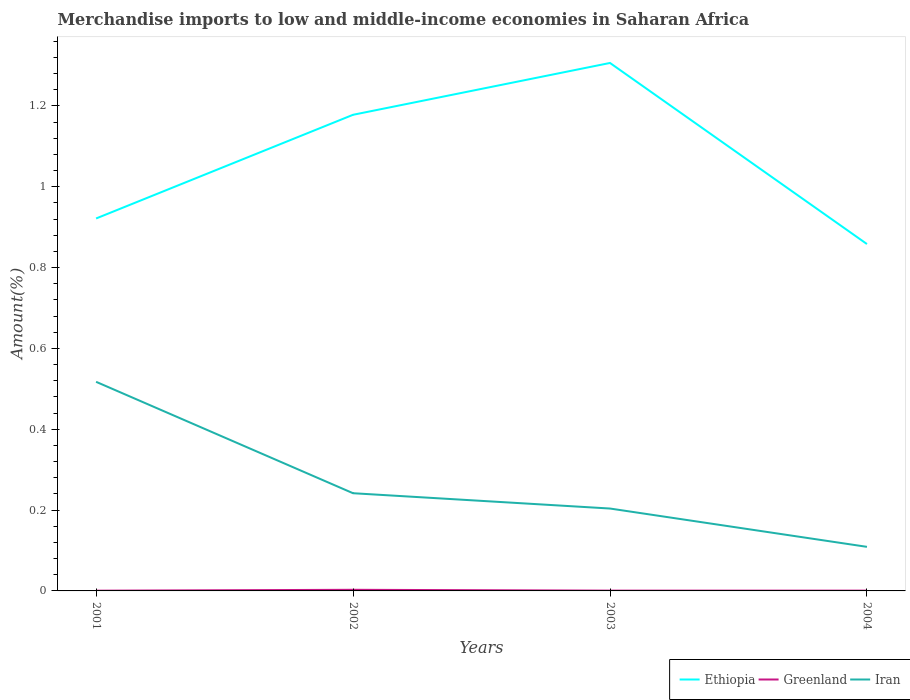Does the line corresponding to Ethiopia intersect with the line corresponding to Greenland?
Your answer should be compact. No. Across all years, what is the maximum percentage of amount earned from merchandise imports in Iran?
Your answer should be very brief. 0.11. What is the total percentage of amount earned from merchandise imports in Ethiopia in the graph?
Your answer should be compact. -0.26. What is the difference between the highest and the second highest percentage of amount earned from merchandise imports in Ethiopia?
Your answer should be very brief. 0.45. What is the difference between the highest and the lowest percentage of amount earned from merchandise imports in Ethiopia?
Provide a short and direct response. 2. How many lines are there?
Make the answer very short. 3. How many years are there in the graph?
Your answer should be very brief. 4. What is the difference between two consecutive major ticks on the Y-axis?
Your answer should be compact. 0.2. Are the values on the major ticks of Y-axis written in scientific E-notation?
Your answer should be compact. No. Does the graph contain grids?
Your answer should be very brief. No. What is the title of the graph?
Ensure brevity in your answer.  Merchandise imports to low and middle-income economies in Saharan Africa. What is the label or title of the X-axis?
Your response must be concise. Years. What is the label or title of the Y-axis?
Provide a short and direct response. Amount(%). What is the Amount(%) in Ethiopia in 2001?
Provide a succinct answer. 0.92. What is the Amount(%) of Greenland in 2001?
Offer a very short reply. 0. What is the Amount(%) in Iran in 2001?
Keep it short and to the point. 0.52. What is the Amount(%) in Ethiopia in 2002?
Provide a succinct answer. 1.18. What is the Amount(%) in Greenland in 2002?
Your response must be concise. 0. What is the Amount(%) of Iran in 2002?
Your answer should be compact. 0.24. What is the Amount(%) in Ethiopia in 2003?
Ensure brevity in your answer.  1.31. What is the Amount(%) in Greenland in 2003?
Offer a terse response. 0. What is the Amount(%) of Iran in 2003?
Keep it short and to the point. 0.2. What is the Amount(%) in Ethiopia in 2004?
Make the answer very short. 0.86. What is the Amount(%) in Greenland in 2004?
Your response must be concise. 0. What is the Amount(%) in Iran in 2004?
Offer a terse response. 0.11. Across all years, what is the maximum Amount(%) of Ethiopia?
Ensure brevity in your answer.  1.31. Across all years, what is the maximum Amount(%) in Greenland?
Give a very brief answer. 0. Across all years, what is the maximum Amount(%) of Iran?
Make the answer very short. 0.52. Across all years, what is the minimum Amount(%) of Ethiopia?
Your answer should be very brief. 0.86. Across all years, what is the minimum Amount(%) of Greenland?
Offer a terse response. 0. Across all years, what is the minimum Amount(%) of Iran?
Give a very brief answer. 0.11. What is the total Amount(%) in Ethiopia in the graph?
Make the answer very short. 4.26. What is the total Amount(%) of Greenland in the graph?
Provide a succinct answer. 0. What is the total Amount(%) of Iran in the graph?
Make the answer very short. 1.07. What is the difference between the Amount(%) in Ethiopia in 2001 and that in 2002?
Your response must be concise. -0.26. What is the difference between the Amount(%) of Greenland in 2001 and that in 2002?
Your response must be concise. -0. What is the difference between the Amount(%) of Iran in 2001 and that in 2002?
Make the answer very short. 0.28. What is the difference between the Amount(%) in Ethiopia in 2001 and that in 2003?
Your response must be concise. -0.38. What is the difference between the Amount(%) of Greenland in 2001 and that in 2003?
Your answer should be very brief. -0. What is the difference between the Amount(%) of Iran in 2001 and that in 2003?
Offer a very short reply. 0.31. What is the difference between the Amount(%) in Ethiopia in 2001 and that in 2004?
Offer a terse response. 0.06. What is the difference between the Amount(%) in Greenland in 2001 and that in 2004?
Give a very brief answer. -0. What is the difference between the Amount(%) in Iran in 2001 and that in 2004?
Offer a very short reply. 0.41. What is the difference between the Amount(%) in Ethiopia in 2002 and that in 2003?
Give a very brief answer. -0.13. What is the difference between the Amount(%) of Greenland in 2002 and that in 2003?
Give a very brief answer. 0. What is the difference between the Amount(%) in Iran in 2002 and that in 2003?
Your response must be concise. 0.04. What is the difference between the Amount(%) of Ethiopia in 2002 and that in 2004?
Your answer should be compact. 0.32. What is the difference between the Amount(%) in Greenland in 2002 and that in 2004?
Provide a short and direct response. 0. What is the difference between the Amount(%) of Iran in 2002 and that in 2004?
Offer a very short reply. 0.13. What is the difference between the Amount(%) of Ethiopia in 2003 and that in 2004?
Offer a terse response. 0.45. What is the difference between the Amount(%) of Greenland in 2003 and that in 2004?
Keep it short and to the point. 0. What is the difference between the Amount(%) of Iran in 2003 and that in 2004?
Provide a succinct answer. 0.09. What is the difference between the Amount(%) in Ethiopia in 2001 and the Amount(%) in Greenland in 2002?
Offer a terse response. 0.92. What is the difference between the Amount(%) of Ethiopia in 2001 and the Amount(%) of Iran in 2002?
Offer a terse response. 0.68. What is the difference between the Amount(%) in Greenland in 2001 and the Amount(%) in Iran in 2002?
Ensure brevity in your answer.  -0.24. What is the difference between the Amount(%) in Ethiopia in 2001 and the Amount(%) in Greenland in 2003?
Your answer should be compact. 0.92. What is the difference between the Amount(%) in Ethiopia in 2001 and the Amount(%) in Iran in 2003?
Your answer should be compact. 0.72. What is the difference between the Amount(%) of Greenland in 2001 and the Amount(%) of Iran in 2003?
Your answer should be compact. -0.2. What is the difference between the Amount(%) in Ethiopia in 2001 and the Amount(%) in Greenland in 2004?
Your answer should be compact. 0.92. What is the difference between the Amount(%) of Ethiopia in 2001 and the Amount(%) of Iran in 2004?
Give a very brief answer. 0.81. What is the difference between the Amount(%) of Greenland in 2001 and the Amount(%) of Iran in 2004?
Your answer should be compact. -0.11. What is the difference between the Amount(%) in Ethiopia in 2002 and the Amount(%) in Greenland in 2003?
Your answer should be compact. 1.18. What is the difference between the Amount(%) of Ethiopia in 2002 and the Amount(%) of Iran in 2003?
Ensure brevity in your answer.  0.97. What is the difference between the Amount(%) of Greenland in 2002 and the Amount(%) of Iran in 2003?
Offer a very short reply. -0.2. What is the difference between the Amount(%) in Ethiopia in 2002 and the Amount(%) in Greenland in 2004?
Keep it short and to the point. 1.18. What is the difference between the Amount(%) in Ethiopia in 2002 and the Amount(%) in Iran in 2004?
Provide a succinct answer. 1.07. What is the difference between the Amount(%) of Greenland in 2002 and the Amount(%) of Iran in 2004?
Provide a short and direct response. -0.11. What is the difference between the Amount(%) of Ethiopia in 2003 and the Amount(%) of Greenland in 2004?
Keep it short and to the point. 1.31. What is the difference between the Amount(%) of Ethiopia in 2003 and the Amount(%) of Iran in 2004?
Provide a succinct answer. 1.2. What is the difference between the Amount(%) in Greenland in 2003 and the Amount(%) in Iran in 2004?
Make the answer very short. -0.11. What is the average Amount(%) of Ethiopia per year?
Your answer should be compact. 1.07. What is the average Amount(%) in Greenland per year?
Make the answer very short. 0. What is the average Amount(%) of Iran per year?
Offer a terse response. 0.27. In the year 2001, what is the difference between the Amount(%) in Ethiopia and Amount(%) in Greenland?
Ensure brevity in your answer.  0.92. In the year 2001, what is the difference between the Amount(%) of Ethiopia and Amount(%) of Iran?
Your answer should be very brief. 0.4. In the year 2001, what is the difference between the Amount(%) of Greenland and Amount(%) of Iran?
Offer a terse response. -0.52. In the year 2002, what is the difference between the Amount(%) of Ethiopia and Amount(%) of Greenland?
Ensure brevity in your answer.  1.18. In the year 2002, what is the difference between the Amount(%) of Ethiopia and Amount(%) of Iran?
Provide a succinct answer. 0.94. In the year 2002, what is the difference between the Amount(%) in Greenland and Amount(%) in Iran?
Your answer should be very brief. -0.24. In the year 2003, what is the difference between the Amount(%) of Ethiopia and Amount(%) of Greenland?
Your answer should be very brief. 1.31. In the year 2003, what is the difference between the Amount(%) in Ethiopia and Amount(%) in Iran?
Ensure brevity in your answer.  1.1. In the year 2003, what is the difference between the Amount(%) of Greenland and Amount(%) of Iran?
Provide a succinct answer. -0.2. In the year 2004, what is the difference between the Amount(%) in Ethiopia and Amount(%) in Greenland?
Keep it short and to the point. 0.86. In the year 2004, what is the difference between the Amount(%) of Ethiopia and Amount(%) of Iran?
Your answer should be very brief. 0.75. In the year 2004, what is the difference between the Amount(%) of Greenland and Amount(%) of Iran?
Offer a terse response. -0.11. What is the ratio of the Amount(%) of Ethiopia in 2001 to that in 2002?
Your answer should be compact. 0.78. What is the ratio of the Amount(%) of Greenland in 2001 to that in 2002?
Your answer should be compact. 0.21. What is the ratio of the Amount(%) of Iran in 2001 to that in 2002?
Keep it short and to the point. 2.14. What is the ratio of the Amount(%) of Ethiopia in 2001 to that in 2003?
Offer a very short reply. 0.71. What is the ratio of the Amount(%) of Greenland in 2001 to that in 2003?
Give a very brief answer. 0.78. What is the ratio of the Amount(%) in Iran in 2001 to that in 2003?
Ensure brevity in your answer.  2.54. What is the ratio of the Amount(%) in Ethiopia in 2001 to that in 2004?
Offer a terse response. 1.07. What is the ratio of the Amount(%) in Greenland in 2001 to that in 2004?
Your response must be concise. 0.79. What is the ratio of the Amount(%) in Iran in 2001 to that in 2004?
Offer a very short reply. 4.74. What is the ratio of the Amount(%) of Ethiopia in 2002 to that in 2003?
Provide a succinct answer. 0.9. What is the ratio of the Amount(%) of Greenland in 2002 to that in 2003?
Offer a very short reply. 3.77. What is the ratio of the Amount(%) of Iran in 2002 to that in 2003?
Your answer should be very brief. 1.19. What is the ratio of the Amount(%) of Ethiopia in 2002 to that in 2004?
Offer a terse response. 1.37. What is the ratio of the Amount(%) of Greenland in 2002 to that in 2004?
Provide a short and direct response. 3.81. What is the ratio of the Amount(%) in Iran in 2002 to that in 2004?
Provide a short and direct response. 2.22. What is the ratio of the Amount(%) in Ethiopia in 2003 to that in 2004?
Keep it short and to the point. 1.52. What is the ratio of the Amount(%) in Greenland in 2003 to that in 2004?
Make the answer very short. 1.01. What is the ratio of the Amount(%) of Iran in 2003 to that in 2004?
Give a very brief answer. 1.87. What is the difference between the highest and the second highest Amount(%) in Ethiopia?
Provide a succinct answer. 0.13. What is the difference between the highest and the second highest Amount(%) in Greenland?
Your response must be concise. 0. What is the difference between the highest and the second highest Amount(%) in Iran?
Your answer should be very brief. 0.28. What is the difference between the highest and the lowest Amount(%) of Ethiopia?
Your response must be concise. 0.45. What is the difference between the highest and the lowest Amount(%) in Greenland?
Your answer should be compact. 0. What is the difference between the highest and the lowest Amount(%) in Iran?
Make the answer very short. 0.41. 